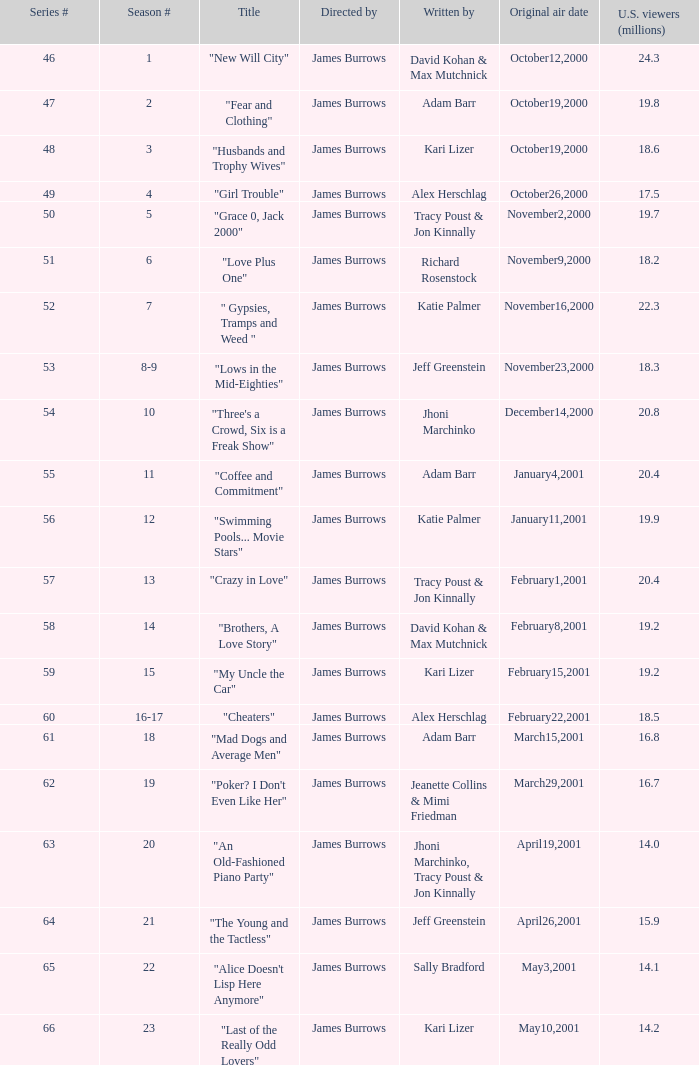Who wrote episode 23 in the season? Kari Lizer. 